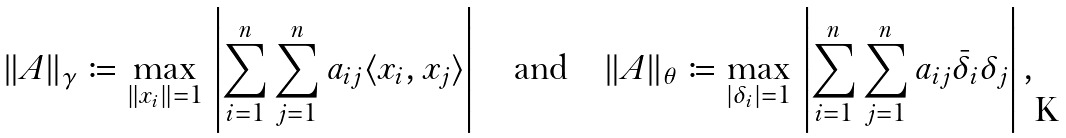<formula> <loc_0><loc_0><loc_500><loc_500>\| A \| _ { \gamma } \coloneqq \max _ { \| x _ { i } \| = 1 } \, \left | \sum _ { i = 1 } ^ { n } \sum _ { j = 1 } ^ { n } a _ { i j } \langle x _ { i } , x _ { j } \rangle \right | \quad \text {and} \quad \| A \| _ { \theta } \coloneqq \max _ { | \delta _ { i } | = 1 } \, \left | \sum _ { i = 1 } ^ { n } \sum _ { j = 1 } ^ { n } a _ { i j } \bar { \delta } _ { i } \delta _ { j } \right | ,</formula> 